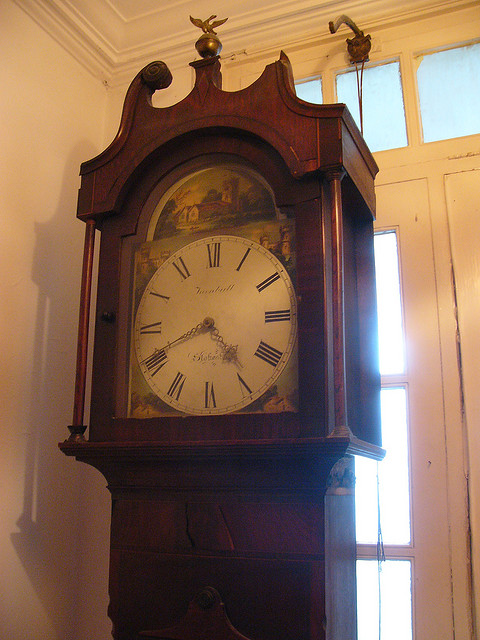<image>What country is the clock in? It is ambiguous what country the clock is in. It could be in the USA or England. What country is the clock in? It is unknown what country the clock is in. It can be seen in the USA or England. 